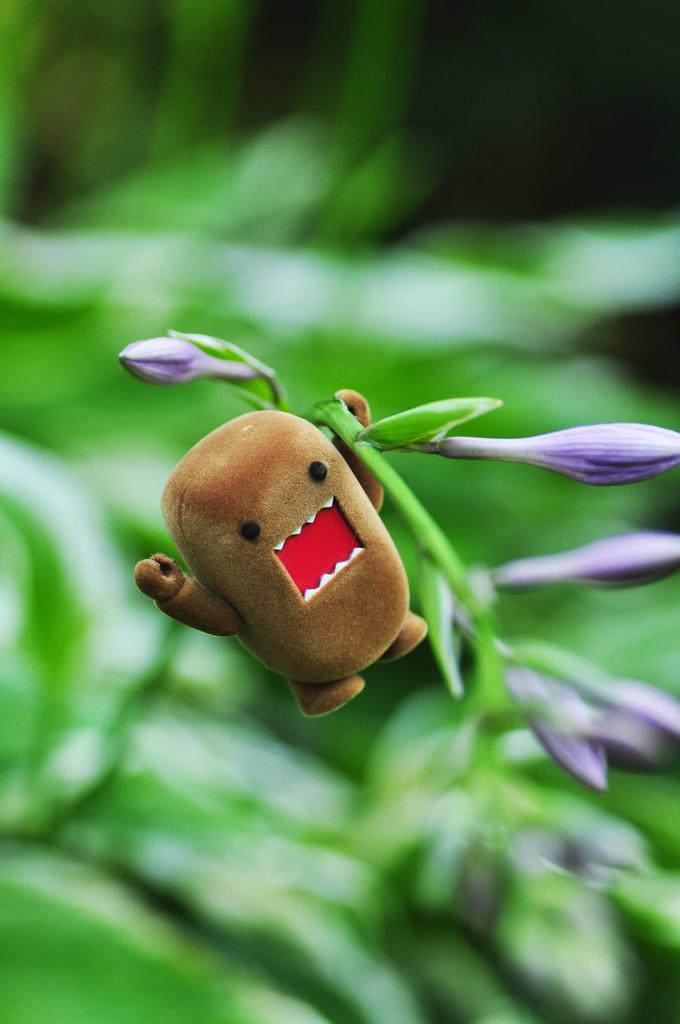What type of plant life is visible in the image? There are flower buds in the image. What is the color of the object in the center of the image? The object in the center of the image is brown. How would you describe the quality of the image's background? The image is blurry in the background. What advice does the daughter give to the authority figure in the image? There is no daughter or authority figure present in the image, so it is not possible to answer that question. 